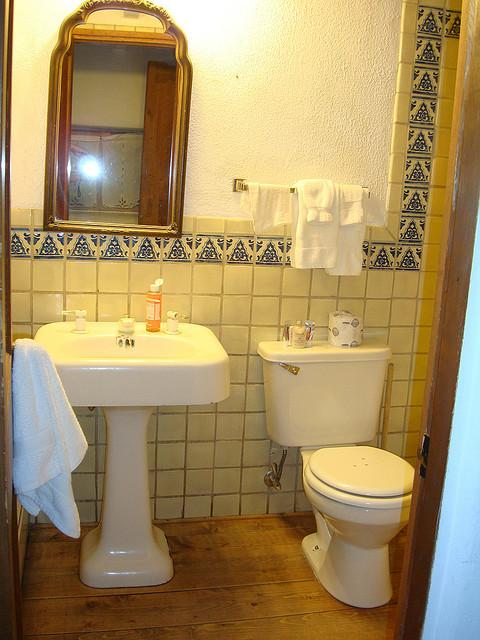Why do sanitary items comes in white color?

Choices:
A) cleanliness
B) none
C) code
D) protection cleanliness 